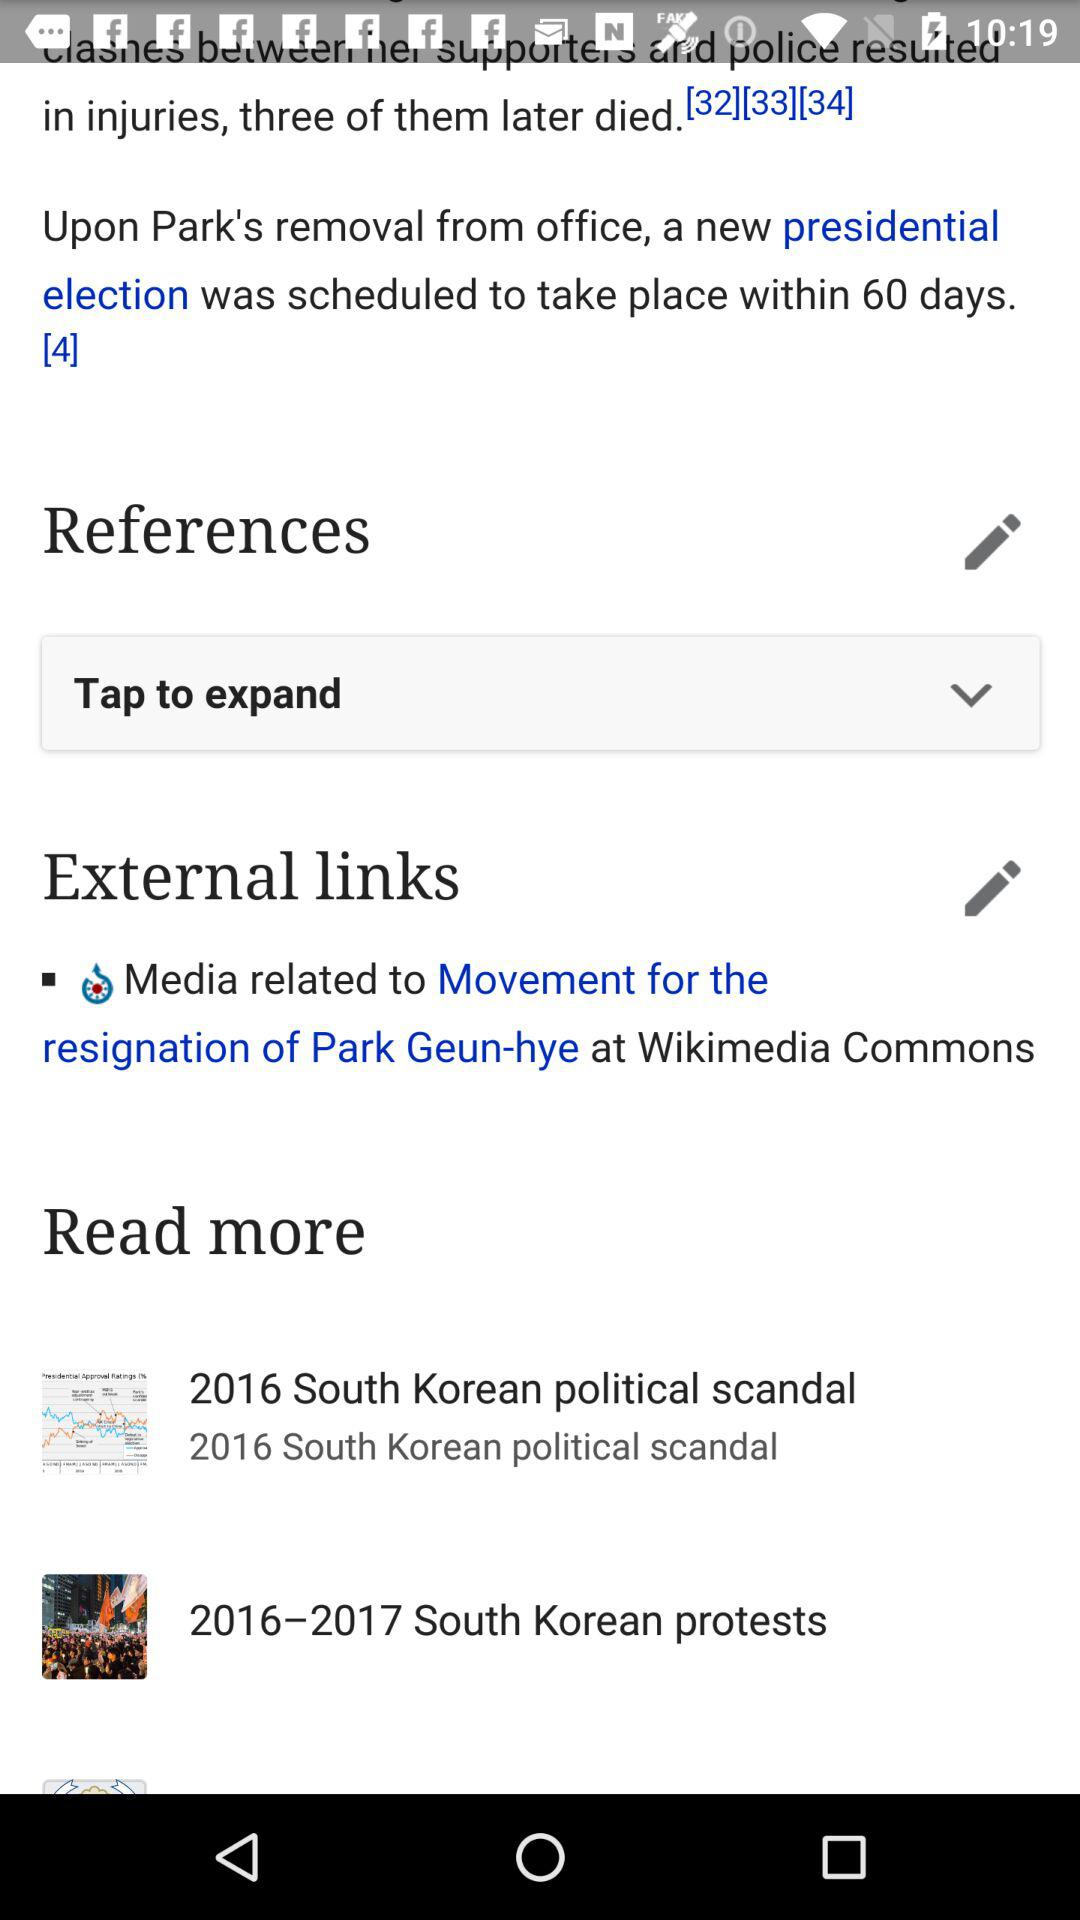In which year did the South Korean scandal happen? The South Korean scandal happened in 2016. 